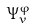<formula> <loc_0><loc_0><loc_500><loc_500>\Psi _ { v } ^ { \varphi }</formula> 